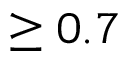Convert formula to latex. <formula><loc_0><loc_0><loc_500><loc_500>\geq 0 . 7</formula> 